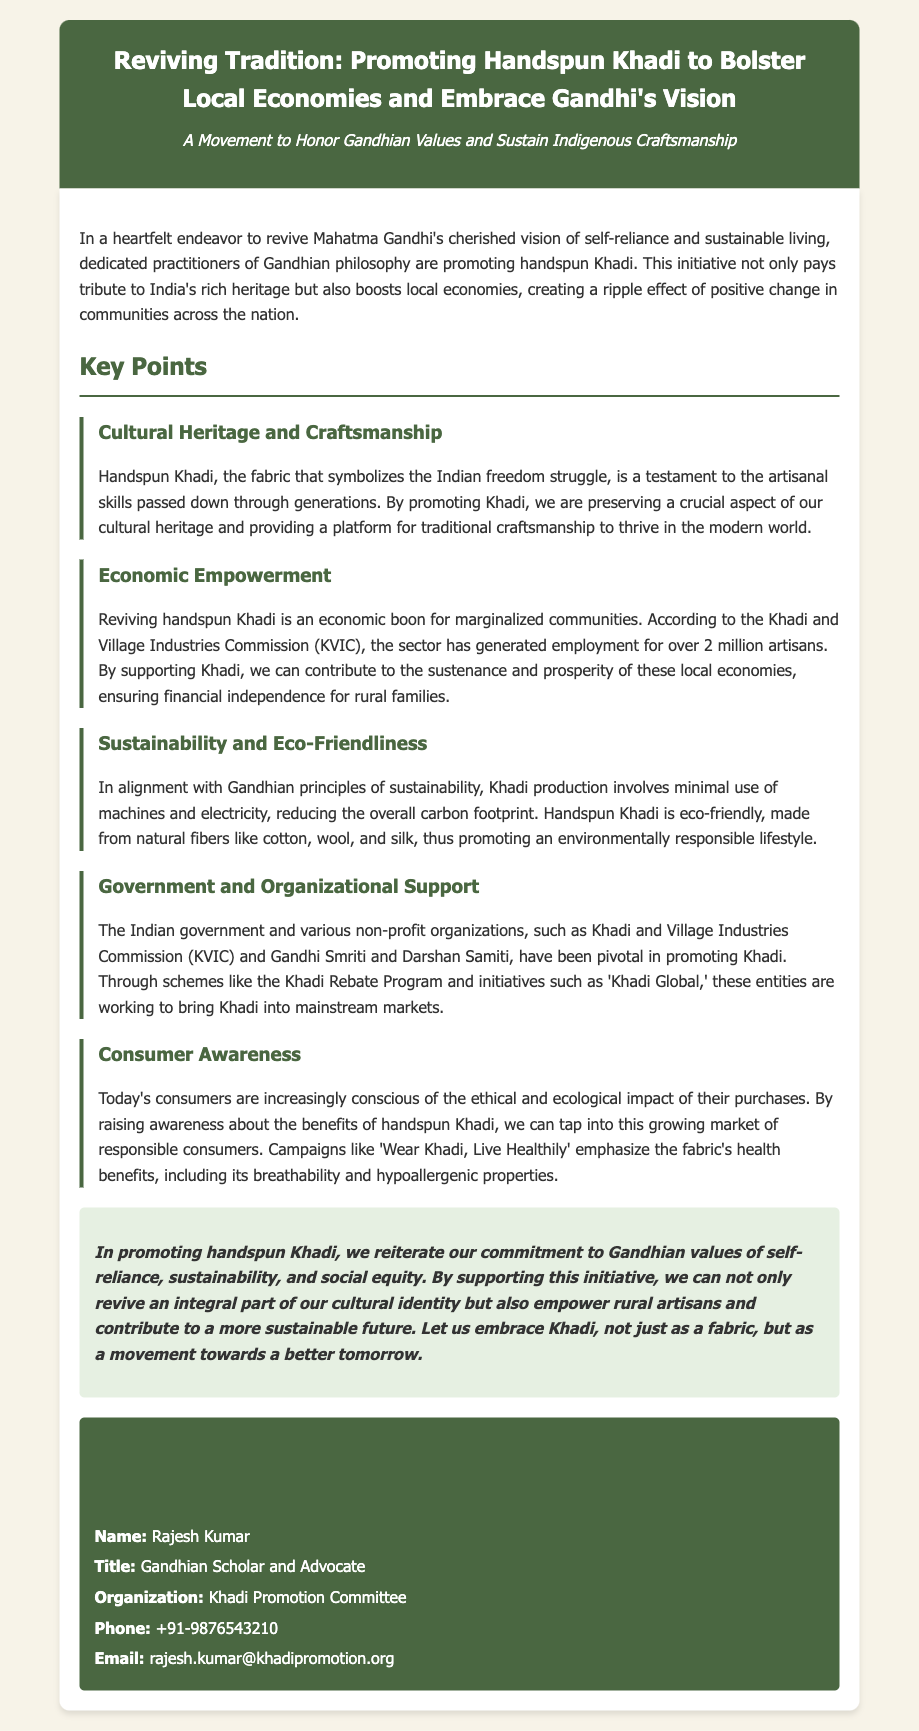What is the title of the press release? The title of the press release is presented prominently at the top and summarizes the document's main theme.
Answer: Reviving Tradition: Promoting Handspun Khadi to Bolster Local Economies and Embrace Gandhi's Vision Who is the contact person for this initiative? The contact person is mentioned in the contact information section of the document.
Answer: Rajesh Kumar How many artisans have found employment in the Khadi sector according to KVIC? The document provides a specific statistic regarding employment generated by the Khadi sector.
Answer: Over 2 million artisans Name one type of fabric used for handspun Khadi. The document lists several natural fibers used in Khadi production.
Answer: Cotton What are the two key benefits highlighted in the conclusion regarding promoting Khadi? The conclusion summarizes the main benefits of promoting Khadi, emphasizing its cultural and economic significance.
Answer: Cultural identity and empower rural artisans Which organization is mentioned as pivotal in promoting Khadi? The document includes specific organizations that support Khadi initiatives.
Answer: Khadi and Village Industries Commission (KVIC) What is the theme of the movement promoting handspun Khadi? The press release emphasizes the overarching theme related to Gandhian values that the movement upholds.
Answer: Honor Gandhian Values and Sustain Indigenous Craftsmanship What is the phone number for the contact person? The document provides specific contact information, including a phone number.
Answer: +91-9876543210 